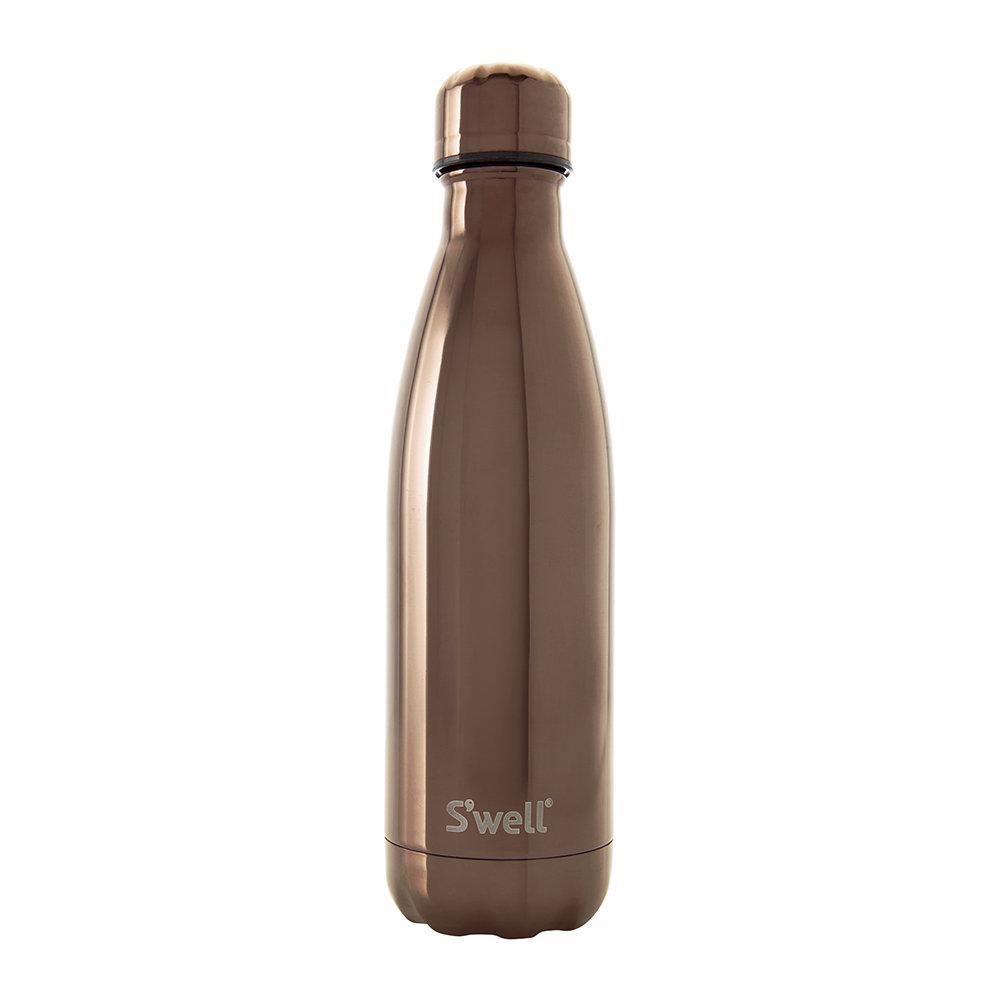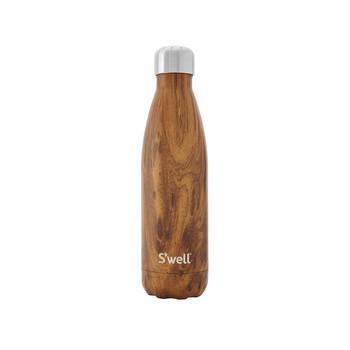The first image is the image on the left, the second image is the image on the right. For the images displayed, is the sentence "the bottle on the left image has a wooden look" factually correct? Answer yes or no. No. 